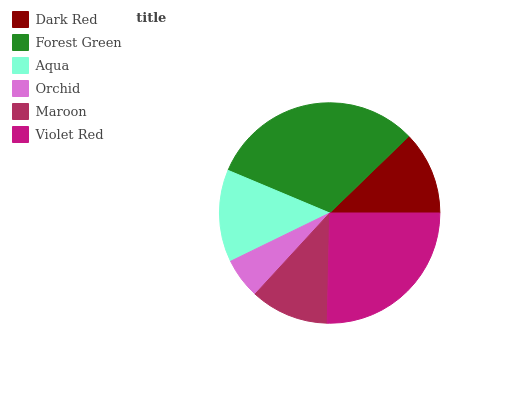Is Orchid the minimum?
Answer yes or no. Yes. Is Forest Green the maximum?
Answer yes or no. Yes. Is Aqua the minimum?
Answer yes or no. No. Is Aqua the maximum?
Answer yes or no. No. Is Forest Green greater than Aqua?
Answer yes or no. Yes. Is Aqua less than Forest Green?
Answer yes or no. Yes. Is Aqua greater than Forest Green?
Answer yes or no. No. Is Forest Green less than Aqua?
Answer yes or no. No. Is Aqua the high median?
Answer yes or no. Yes. Is Dark Red the low median?
Answer yes or no. Yes. Is Dark Red the high median?
Answer yes or no. No. Is Orchid the low median?
Answer yes or no. No. 